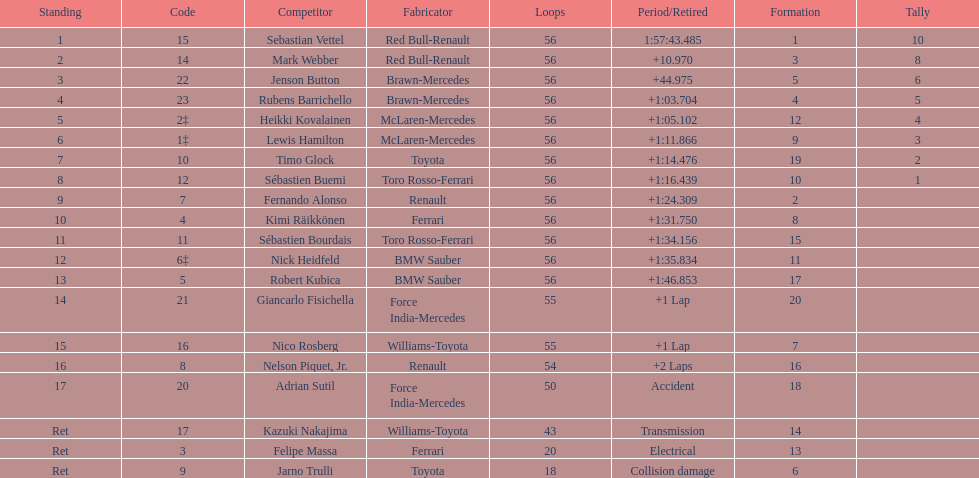Which driver is the only driver who retired because of collision damage? Jarno Trulli. Give me the full table as a dictionary. {'header': ['Standing', 'Code', 'Competitor', 'Fabricator', 'Loops', 'Period/Retired', 'Formation', 'Tally'], 'rows': [['1', '15', 'Sebastian Vettel', 'Red Bull-Renault', '56', '1:57:43.485', '1', '10'], ['2', '14', 'Mark Webber', 'Red Bull-Renault', '56', '+10.970', '3', '8'], ['3', '22', 'Jenson Button', 'Brawn-Mercedes', '56', '+44.975', '5', '6'], ['4', '23', 'Rubens Barrichello', 'Brawn-Mercedes', '56', '+1:03.704', '4', '5'], ['5', '2‡', 'Heikki Kovalainen', 'McLaren-Mercedes', '56', '+1:05.102', '12', '4'], ['6', '1‡', 'Lewis Hamilton', 'McLaren-Mercedes', '56', '+1:11.866', '9', '3'], ['7', '10', 'Timo Glock', 'Toyota', '56', '+1:14.476', '19', '2'], ['8', '12', 'Sébastien Buemi', 'Toro Rosso-Ferrari', '56', '+1:16.439', '10', '1'], ['9', '7', 'Fernando Alonso', 'Renault', '56', '+1:24.309', '2', ''], ['10', '4', 'Kimi Räikkönen', 'Ferrari', '56', '+1:31.750', '8', ''], ['11', '11', 'Sébastien Bourdais', 'Toro Rosso-Ferrari', '56', '+1:34.156', '15', ''], ['12', '6‡', 'Nick Heidfeld', 'BMW Sauber', '56', '+1:35.834', '11', ''], ['13', '5', 'Robert Kubica', 'BMW Sauber', '56', '+1:46.853', '17', ''], ['14', '21', 'Giancarlo Fisichella', 'Force India-Mercedes', '55', '+1 Lap', '20', ''], ['15', '16', 'Nico Rosberg', 'Williams-Toyota', '55', '+1 Lap', '7', ''], ['16', '8', 'Nelson Piquet, Jr.', 'Renault', '54', '+2 Laps', '16', ''], ['17', '20', 'Adrian Sutil', 'Force India-Mercedes', '50', 'Accident', '18', ''], ['Ret', '17', 'Kazuki Nakajima', 'Williams-Toyota', '43', 'Transmission', '14', ''], ['Ret', '3', 'Felipe Massa', 'Ferrari', '20', 'Electrical', '13', ''], ['Ret', '9', 'Jarno Trulli', 'Toyota', '18', 'Collision damage', '6', '']]} 